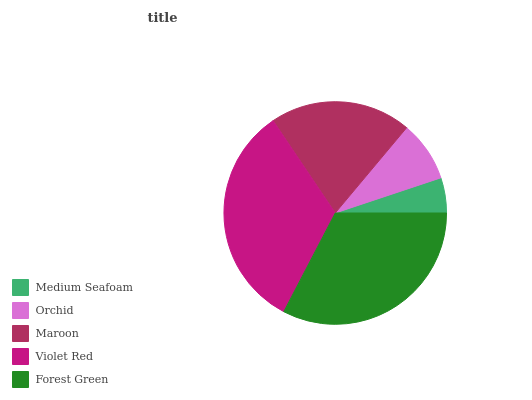Is Medium Seafoam the minimum?
Answer yes or no. Yes. Is Violet Red the maximum?
Answer yes or no. Yes. Is Orchid the minimum?
Answer yes or no. No. Is Orchid the maximum?
Answer yes or no. No. Is Orchid greater than Medium Seafoam?
Answer yes or no. Yes. Is Medium Seafoam less than Orchid?
Answer yes or no. Yes. Is Medium Seafoam greater than Orchid?
Answer yes or no. No. Is Orchid less than Medium Seafoam?
Answer yes or no. No. Is Maroon the high median?
Answer yes or no. Yes. Is Maroon the low median?
Answer yes or no. Yes. Is Medium Seafoam the high median?
Answer yes or no. No. Is Orchid the low median?
Answer yes or no. No. 